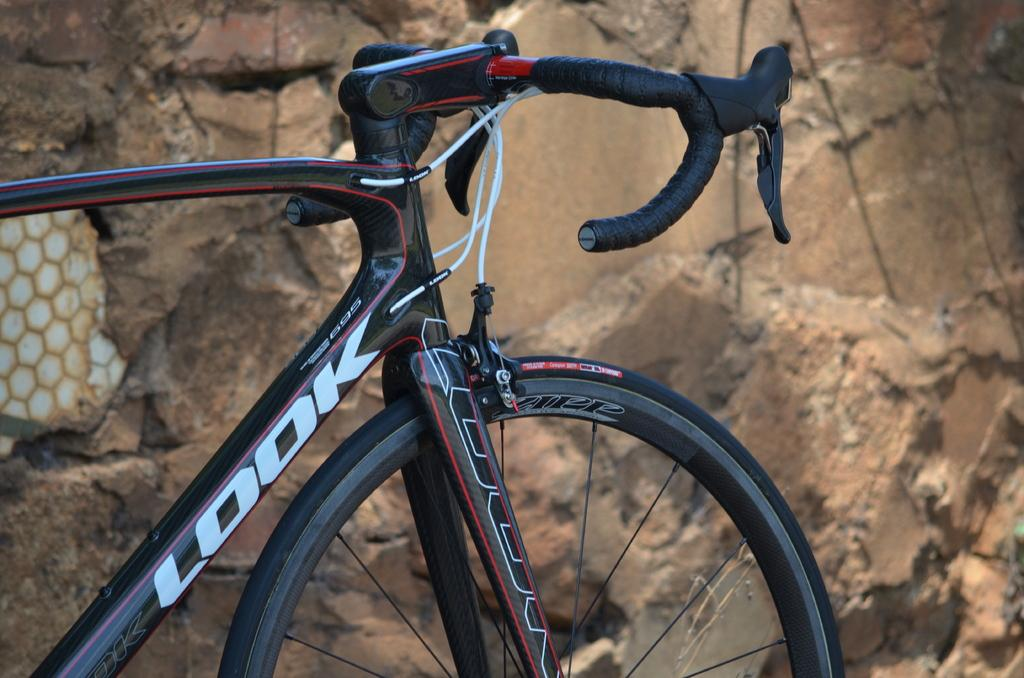What is the main subject of the picture? The main subject of the picture is a bicycle. Where is the bicycle located in relation to other objects in the image? The bicycle is near a wall. What can be seen on the left side of the image? There is a white object on the left side of the image. What type of sofa is visible in the image? There is no sofa present in the image. How does the beginner cyclist handle the bicycle in the image? There is no indication of a cyclist, let alone a beginner cyclist, in the image. 